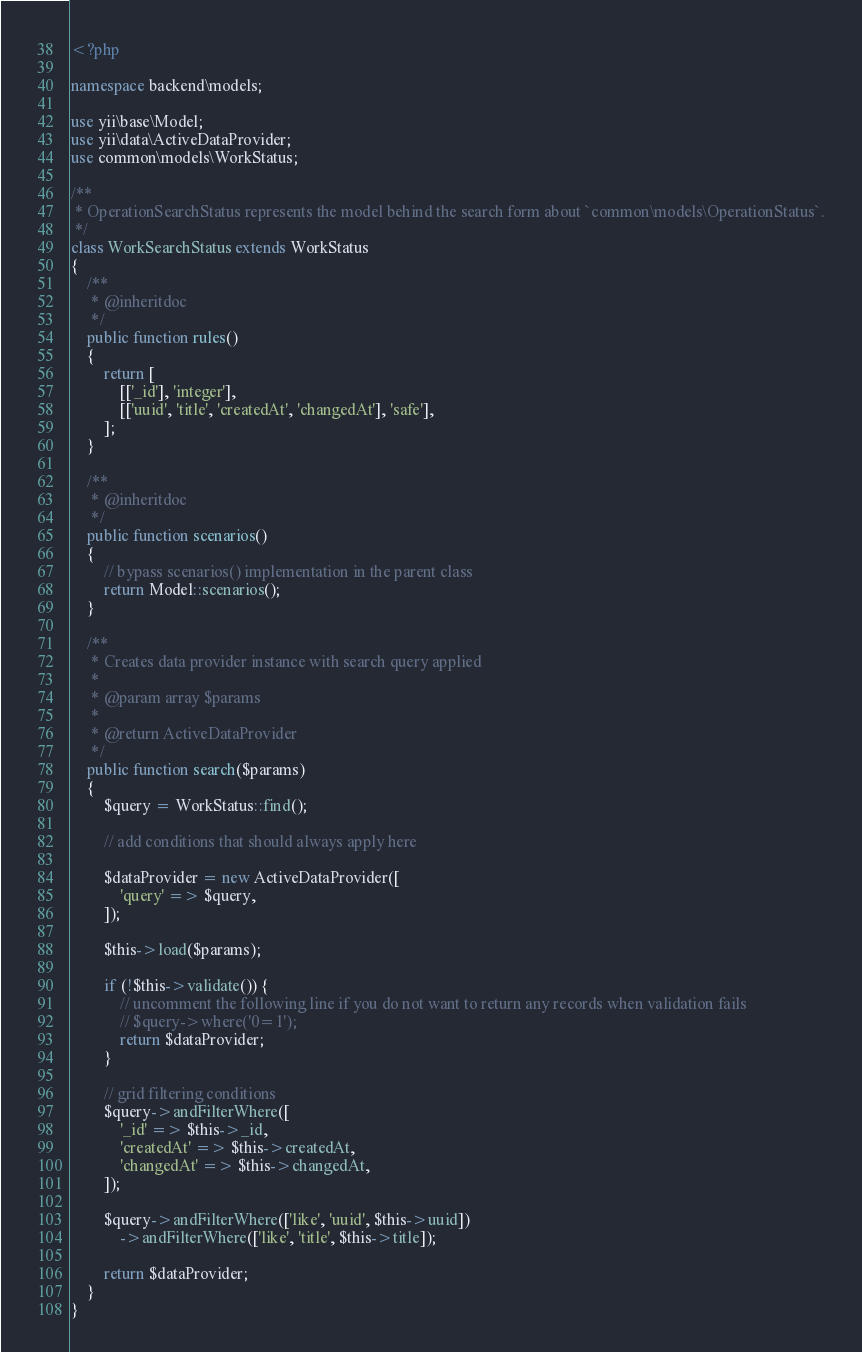Convert code to text. <code><loc_0><loc_0><loc_500><loc_500><_PHP_><?php

namespace backend\models;

use yii\base\Model;
use yii\data\ActiveDataProvider;
use common\models\WorkStatus;

/**
 * OperationSearchStatus represents the model behind the search form about `common\models\OperationStatus`.
 */
class WorkSearchStatus extends WorkStatus
{
    /**
     * @inheritdoc
     */
    public function rules()
    {
        return [
            [['_id'], 'integer'],
            [['uuid', 'title', 'createdAt', 'changedAt'], 'safe'],
        ];
    }

    /**
     * @inheritdoc
     */
    public function scenarios()
    {
        // bypass scenarios() implementation in the parent class
        return Model::scenarios();
    }

    /**
     * Creates data provider instance with search query applied
     *
     * @param array $params
     *
     * @return ActiveDataProvider
     */
    public function search($params)
    {
        $query = WorkStatus::find();

        // add conditions that should always apply here

        $dataProvider = new ActiveDataProvider([
            'query' => $query,
        ]);

        $this->load($params);

        if (!$this->validate()) {
            // uncomment the following line if you do not want to return any records when validation fails
            // $query->where('0=1');
            return $dataProvider;
        }

        // grid filtering conditions
        $query->andFilterWhere([
            '_id' => $this->_id,
            'createdAt' => $this->createdAt,
            'changedAt' => $this->changedAt,
        ]);

        $query->andFilterWhere(['like', 'uuid', $this->uuid])
            ->andFilterWhere(['like', 'title', $this->title]);

        return $dataProvider;
    }
}
</code> 